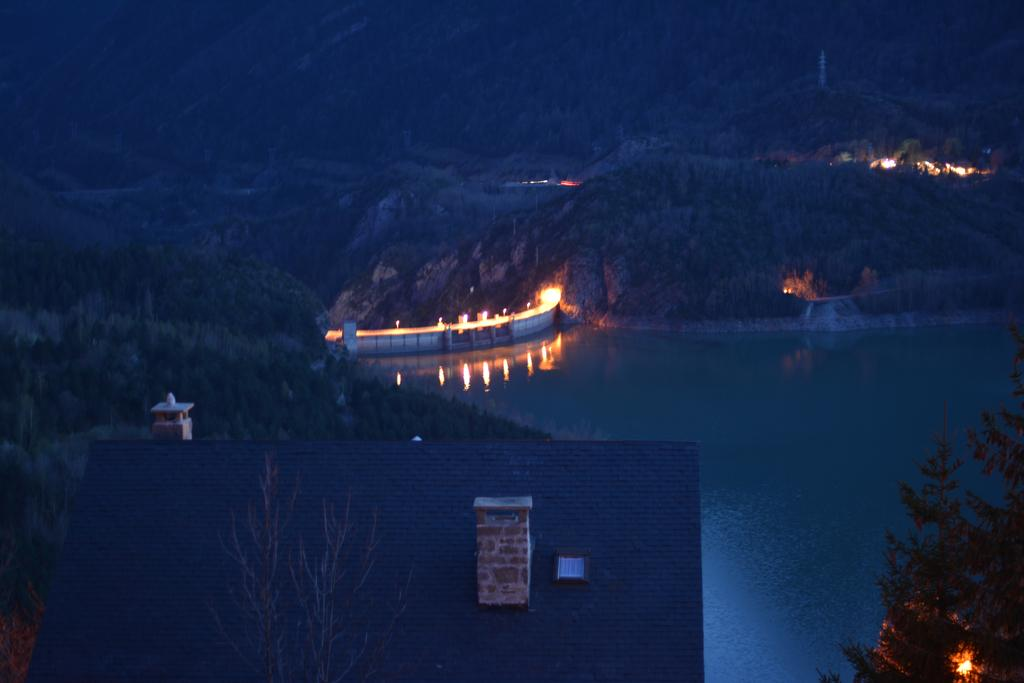At what time of day was the image taken? The image was taken during night time. What type of landscape can be seen in the image? There are hills visible in the image. What other natural elements are present in the image? There are trees in the image. What type of structure is visible in the image? There is a house in the image. What artificial feature can be seen in the image? There is a bridge with lights in the image. What body of water is visible in the image? There is water visible in the image. What type of brain can be seen in the image? There is no brain visible in the image; it features hills, trees, a house, a bridge with lights, and water. How many cars are parked near the house in the image? There is no car present in the image. 